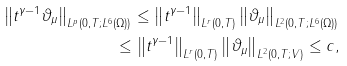<formula> <loc_0><loc_0><loc_500><loc_500>\left \| t ^ { \gamma - 1 } \vartheta _ { \mu } \right \| _ { L ^ { p } ( 0 , T ; L ^ { 6 } ( \Omega ) ) } \leq \left \| t ^ { \gamma - 1 } \right \| _ { L ^ { r } ( 0 , T ) } \left \| \vartheta _ { \mu } \right \| _ { L ^ { 2 } ( 0 , T ; L ^ { 6 } ( \Omega ) ) } \\ \leq \left \| t ^ { \gamma - 1 } \right \| _ { L ^ { r } ( 0 , T ) } \left \| \vartheta _ { \mu } \right \| _ { L ^ { 2 } ( 0 , T ; V ) } \leq c ,</formula> 